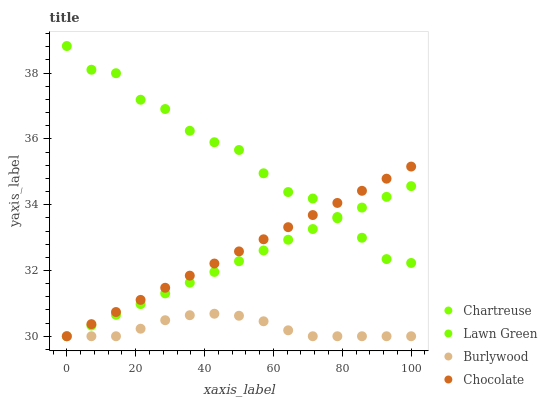Does Burlywood have the minimum area under the curve?
Answer yes or no. Yes. Does Lawn Green have the maximum area under the curve?
Answer yes or no. Yes. Does Chartreuse have the minimum area under the curve?
Answer yes or no. No. Does Chartreuse have the maximum area under the curve?
Answer yes or no. No. Is Chocolate the smoothest?
Answer yes or no. Yes. Is Lawn Green the roughest?
Answer yes or no. Yes. Is Chartreuse the smoothest?
Answer yes or no. No. Is Chartreuse the roughest?
Answer yes or no. No. Does Burlywood have the lowest value?
Answer yes or no. Yes. Does Lawn Green have the lowest value?
Answer yes or no. No. Does Lawn Green have the highest value?
Answer yes or no. Yes. Does Chartreuse have the highest value?
Answer yes or no. No. Is Burlywood less than Lawn Green?
Answer yes or no. Yes. Is Lawn Green greater than Burlywood?
Answer yes or no. Yes. Does Chocolate intersect Burlywood?
Answer yes or no. Yes. Is Chocolate less than Burlywood?
Answer yes or no. No. Is Chocolate greater than Burlywood?
Answer yes or no. No. Does Burlywood intersect Lawn Green?
Answer yes or no. No. 